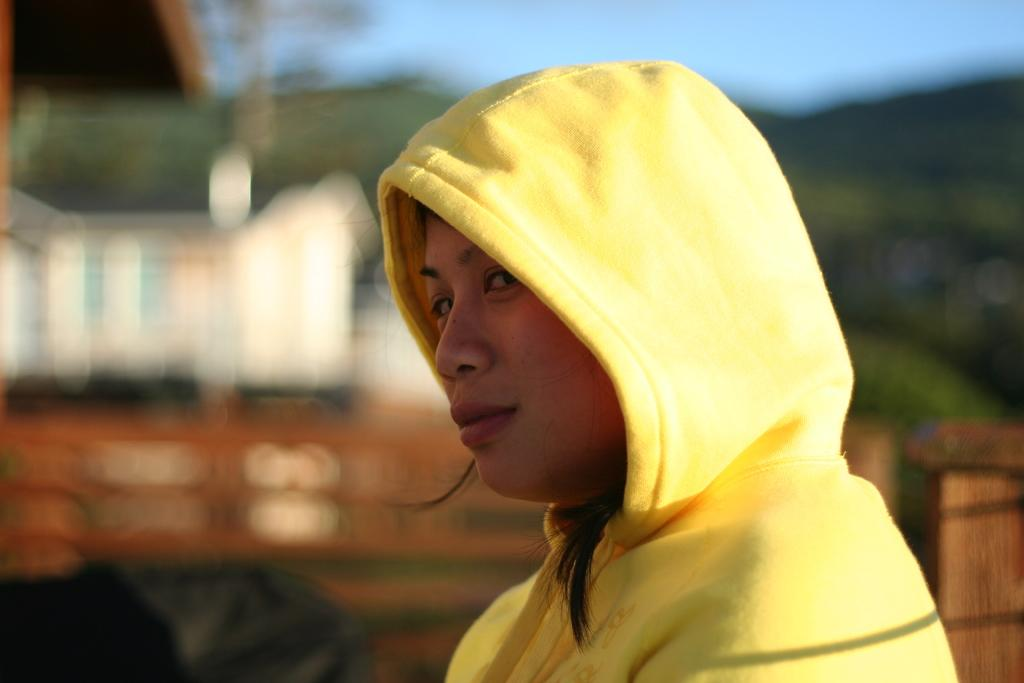Who is the main subject in the image? There is a woman in the middle of the picture. What is the woman wearing in the image? The woman is wearing a yellow hoodie. Can you describe the background of the image? The background of the image is blurred. What type of rock can be seen in the woman's hand in the image? There is no rock present in the image; the woman is not holding anything. 